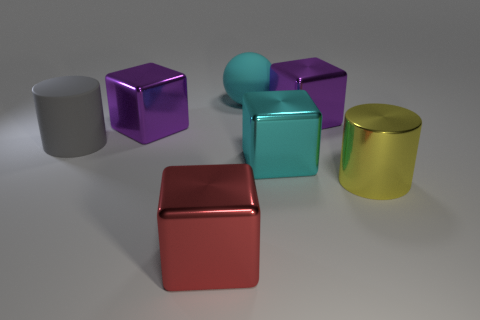Add 2 big red things. How many objects exist? 9 Subtract all cylinders. How many objects are left? 5 Subtract all matte objects. Subtract all small red matte objects. How many objects are left? 5 Add 4 big cyan metallic blocks. How many big cyan metallic blocks are left? 5 Add 4 matte spheres. How many matte spheres exist? 5 Subtract 0 yellow spheres. How many objects are left? 7 